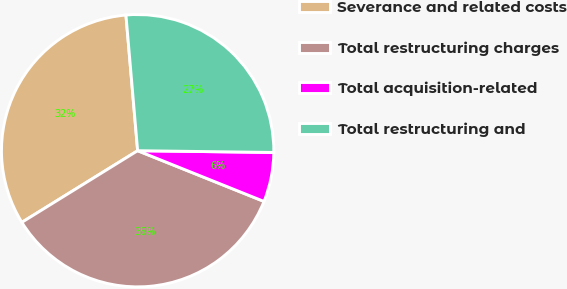Convert chart to OTSL. <chart><loc_0><loc_0><loc_500><loc_500><pie_chart><fcel>Severance and related costs<fcel>Total restructuring charges<fcel>Total acquisition-related<fcel>Total restructuring and<nl><fcel>32.45%<fcel>35.11%<fcel>5.87%<fcel>26.58%<nl></chart> 